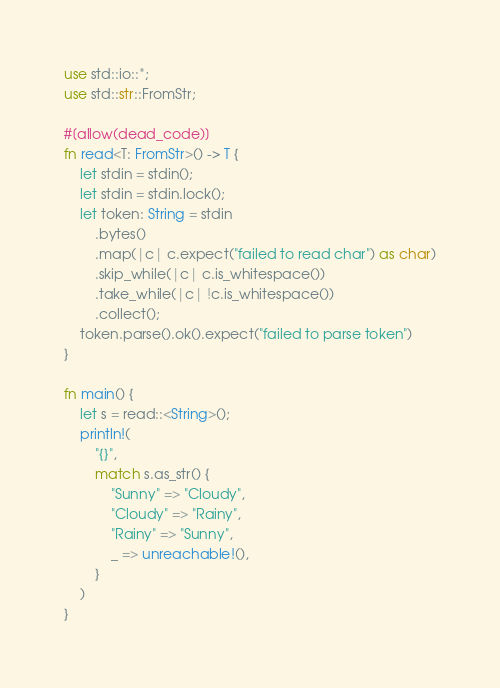Convert code to text. <code><loc_0><loc_0><loc_500><loc_500><_Rust_>use std::io::*;
use std::str::FromStr;

#[allow(dead_code)]
fn read<T: FromStr>() -> T {
    let stdin = stdin();
    let stdin = stdin.lock();
    let token: String = stdin
        .bytes()
        .map(|c| c.expect("failed to read char") as char)
        .skip_while(|c| c.is_whitespace())
        .take_while(|c| !c.is_whitespace())
        .collect();
    token.parse().ok().expect("failed to parse token")
}

fn main() {
    let s = read::<String>();
    println!(
        "{}",
        match s.as_str() {
            "Sunny" => "Cloudy",
            "Cloudy" => "Rainy",
            "Rainy" => "Sunny",
            _ => unreachable!(),
        }
    )
}
</code> 